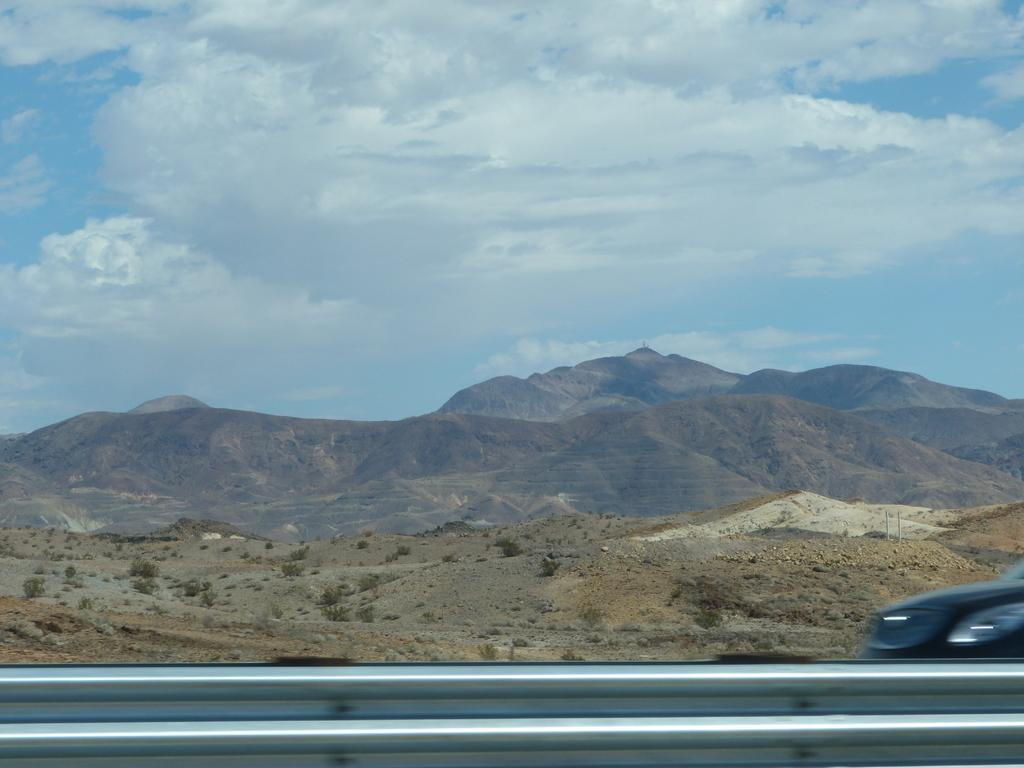What type of landscape can be seen in the image? There are hills in the image. What is visible at the top of the image? The sky is visible at the top of the image. What might be used for safety or support at the bottom of the image? There is a railing at the bottom of the image. What can be seen on the right side of the image? There is a vehicle on the right side of the image. How many cats are sitting on the vehicle in the image? There are no cats present in the image; only the hills, sky, railing, and vehicle can be seen. 